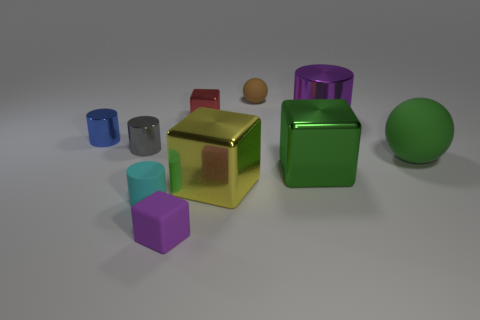What number of things are on the left side of the small brown matte sphere and behind the tiny cyan cylinder?
Provide a succinct answer. 4. How many green objects are rubber balls or big spheres?
Offer a very short reply. 1. There is a small rubber block left of the large ball; is its color the same as the shiny thing that is to the right of the large green metallic thing?
Keep it short and to the point. Yes. There is a rubber sphere on the left side of the rubber object that is to the right of the tiny rubber object that is behind the small rubber cylinder; what is its color?
Provide a short and direct response. Brown. Is there a matte object that is to the left of the small matte object that is right of the small metal block?
Offer a terse response. Yes. Does the big thing to the left of the small brown matte ball have the same shape as the small red shiny object?
Your response must be concise. Yes. How many blocks are yellow objects or large purple metal objects?
Your answer should be compact. 1. How many yellow blocks are there?
Your answer should be compact. 1. How big is the matte thing left of the purple thing in front of the cyan rubber object?
Keep it short and to the point. Small. What number of other things are there of the same size as the green shiny cube?
Offer a very short reply. 3. 